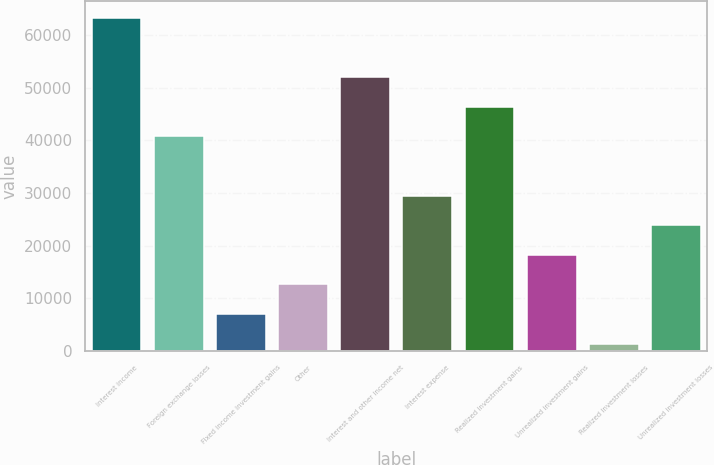<chart> <loc_0><loc_0><loc_500><loc_500><bar_chart><fcel>Interest income<fcel>Foreign exchange losses<fcel>Fixed income investment gains<fcel>Other<fcel>Interest and other income net<fcel>Interest expense<fcel>Realized investment gains<fcel>Unrealized investment gains<fcel>Realized investment losses<fcel>Unrealized investment losses<nl><fcel>63205.1<fcel>40736.7<fcel>7034.1<fcel>12651.2<fcel>51970.9<fcel>29502.5<fcel>46353.8<fcel>18268.3<fcel>1417<fcel>23885.4<nl></chart> 